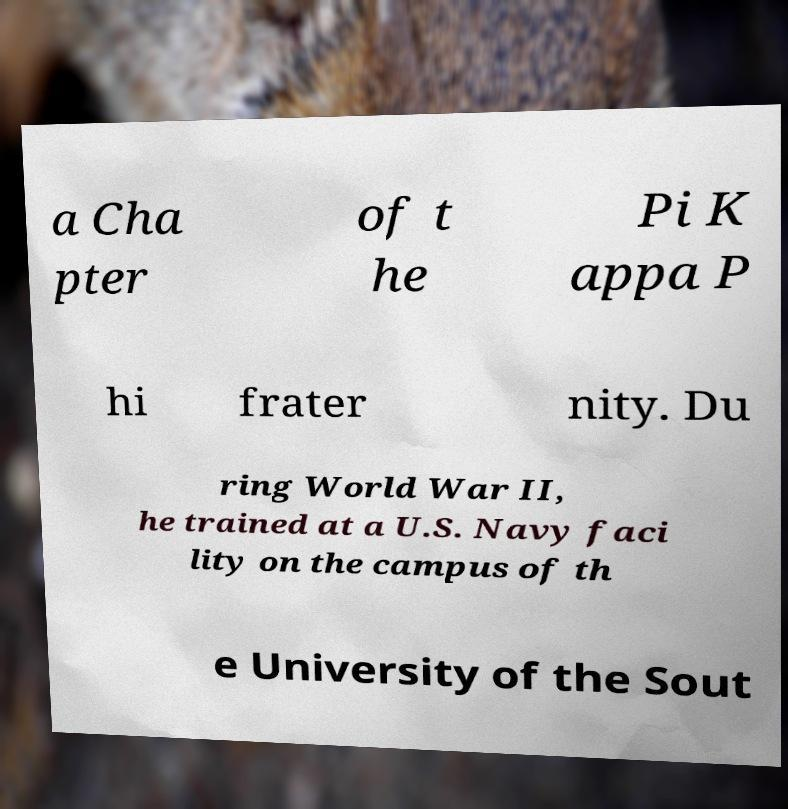Please identify and transcribe the text found in this image. a Cha pter of t he Pi K appa P hi frater nity. Du ring World War II, he trained at a U.S. Navy faci lity on the campus of th e University of the Sout 